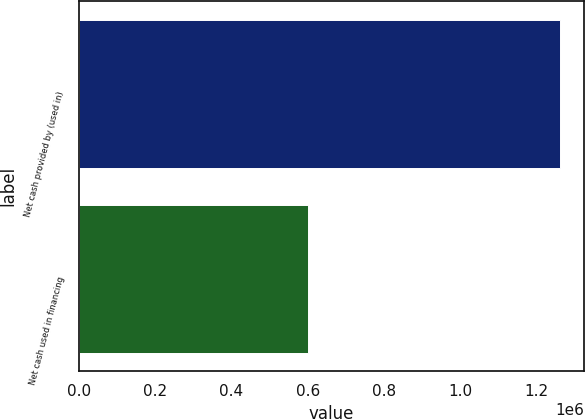Convert chart to OTSL. <chart><loc_0><loc_0><loc_500><loc_500><bar_chart><fcel>Net cash provided by (used in)<fcel>Net cash used in financing<nl><fcel>1.26226e+06<fcel>601254<nl></chart> 